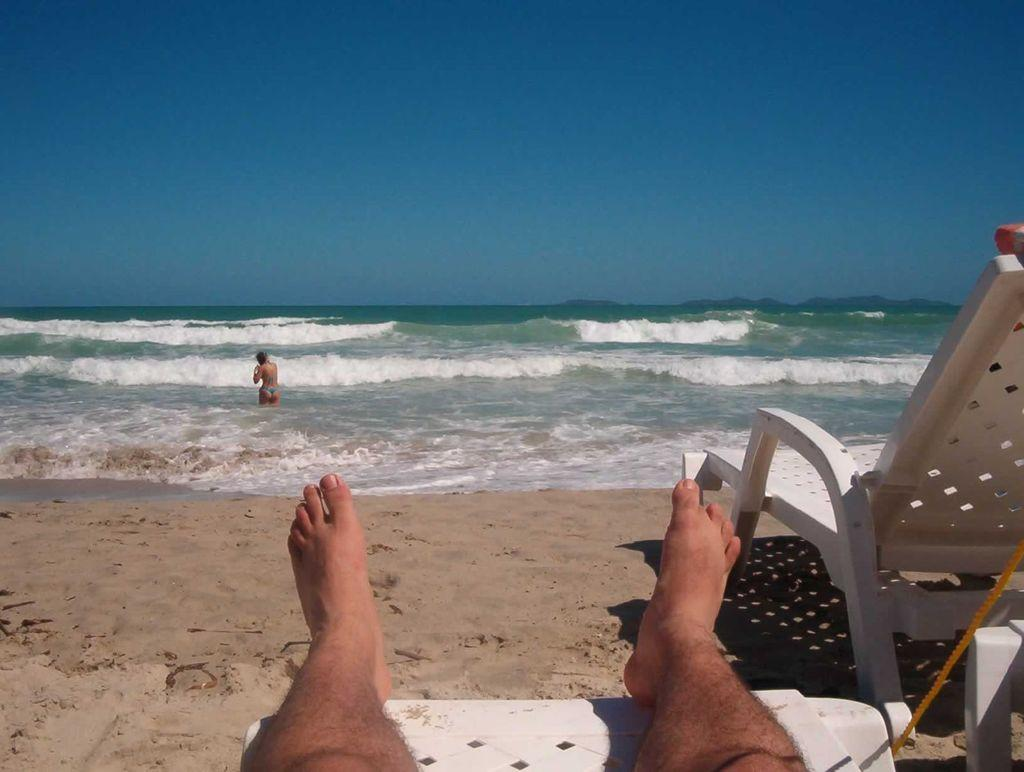What is the person in the image doing? The person is laying on a chair in the image. What color is the chair? The chair is white. Can you describe the background of the image? There is another person in the water in the background of the image. What is the color of the sky in the image? The sky is blue in the image. What type of force is being applied to the person laying on the chair in the image? There is no indication of any force being applied to the person in the image. 